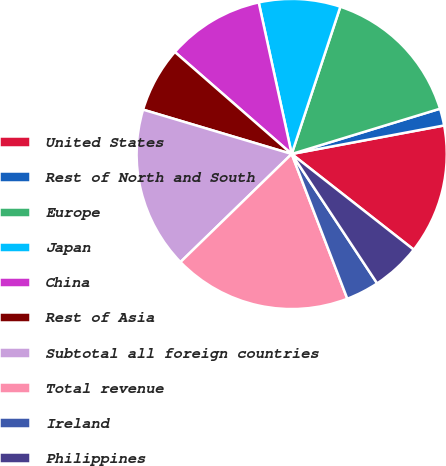Convert chart. <chart><loc_0><loc_0><loc_500><loc_500><pie_chart><fcel>United States<fcel>Rest of North and South<fcel>Europe<fcel>Japan<fcel>China<fcel>Rest of Asia<fcel>Subtotal all foreign countries<fcel>Total revenue<fcel>Ireland<fcel>Philippines<nl><fcel>13.53%<fcel>1.77%<fcel>15.21%<fcel>8.49%<fcel>10.17%<fcel>6.81%<fcel>16.89%<fcel>18.57%<fcel>3.45%<fcel>5.13%<nl></chart> 